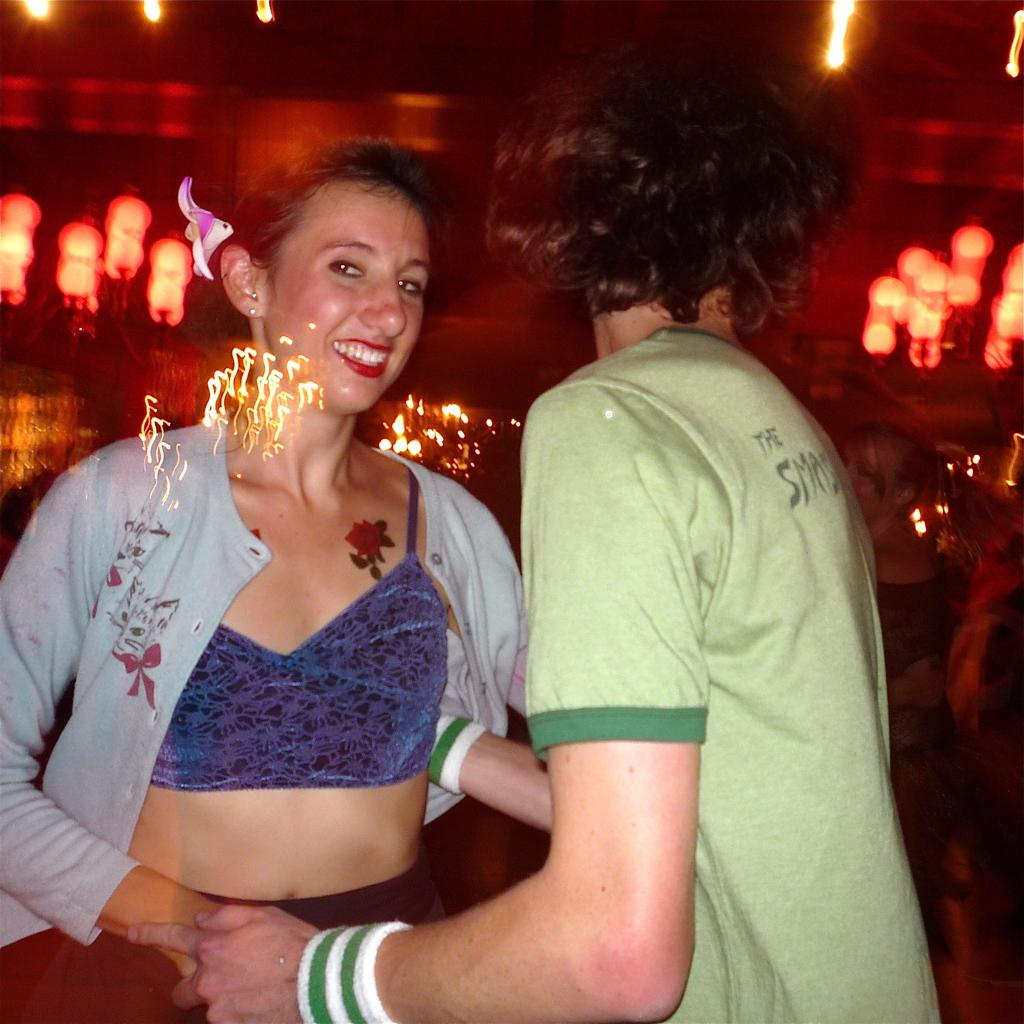What is happening in the image involving two people? There is a couple in the image, and they are dancing. Can you describe the setting of the image? There are lights visible in the background of the image. What type of book is the couple reading together in the image? There is no book present in the image; the couple is dancing. What is the visibility like in the image due to the presence of fog? There is no fog present in the image, so it cannot be determined how visibility might be affected. 